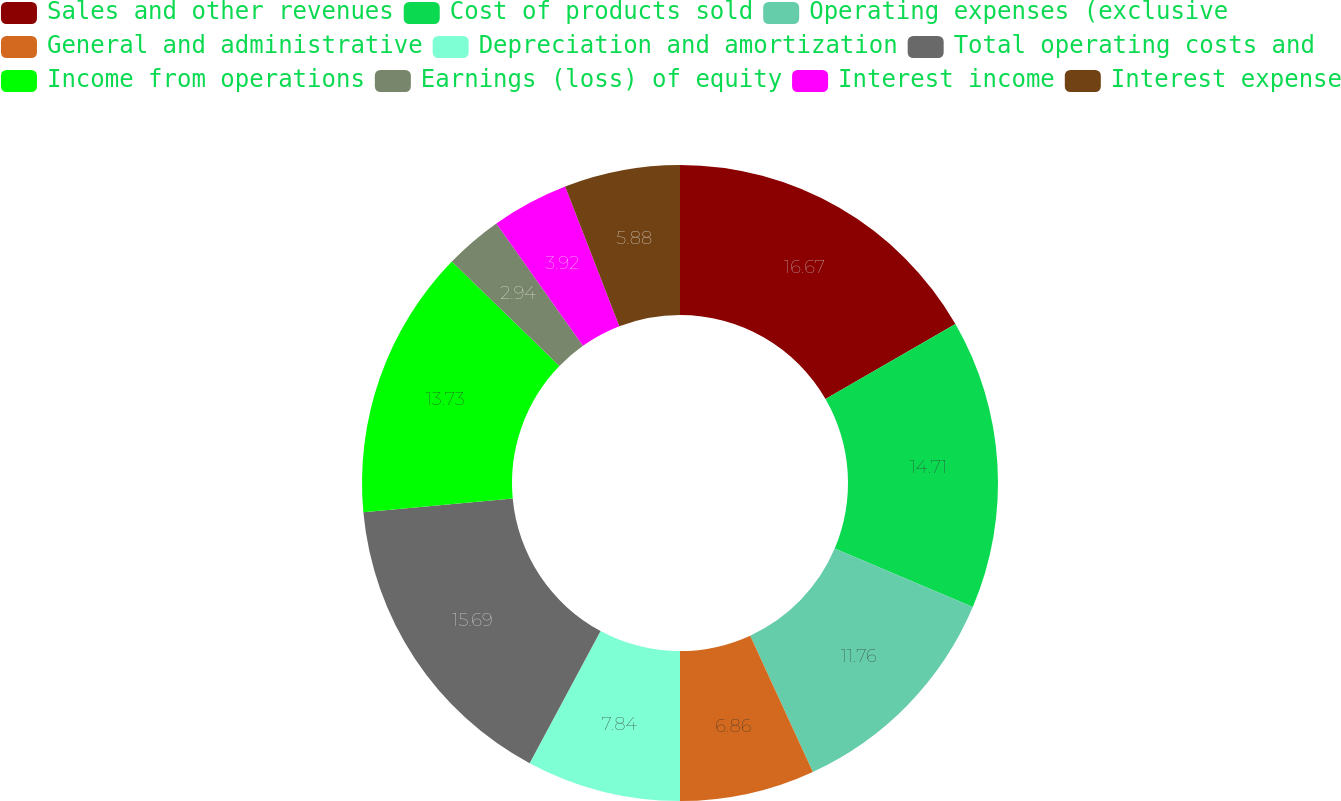Convert chart. <chart><loc_0><loc_0><loc_500><loc_500><pie_chart><fcel>Sales and other revenues<fcel>Cost of products sold<fcel>Operating expenses (exclusive<fcel>General and administrative<fcel>Depreciation and amortization<fcel>Total operating costs and<fcel>Income from operations<fcel>Earnings (loss) of equity<fcel>Interest income<fcel>Interest expense<nl><fcel>16.67%<fcel>14.71%<fcel>11.76%<fcel>6.86%<fcel>7.84%<fcel>15.69%<fcel>13.73%<fcel>2.94%<fcel>3.92%<fcel>5.88%<nl></chart> 